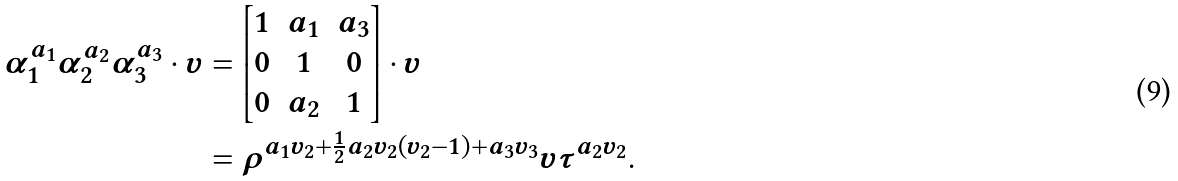<formula> <loc_0><loc_0><loc_500><loc_500>\alpha _ { 1 } ^ { a _ { 1 } } \alpha _ { 2 } ^ { a _ { 2 } } \alpha _ { 3 } ^ { a _ { 3 } } \cdot v & = \begin{bmatrix} 1 & a _ { 1 } & a _ { 3 } \\ 0 & 1 & 0 \\ 0 & a _ { 2 } & 1 \end{bmatrix} \cdot v \\ & = \rho ^ { a _ { 1 } v _ { 2 } + \frac { 1 } { 2 } a _ { 2 } v _ { 2 } \left ( v _ { 2 } - 1 \right ) + a _ { 3 } v _ { 3 } } v \tau ^ { a _ { 2 } v _ { 2 } } .</formula> 